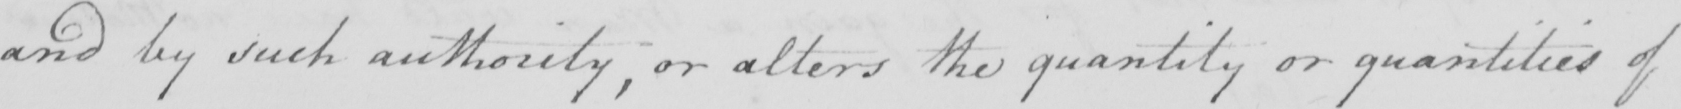What text is written in this handwritten line? and by such authority , or alters the quantity or quantities of 